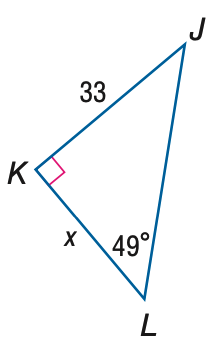Answer the mathemtical geometry problem and directly provide the correct option letter.
Question: Find x. Round to the nearest tenth.
Choices: A: 28.7 B: 38.0 C: 43.7 D: 50.3 A 